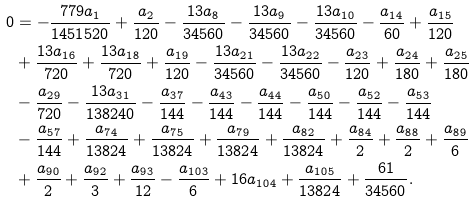<formula> <loc_0><loc_0><loc_500><loc_500>0 & = - \frac { 7 7 9 a _ { 1 } } { 1 4 5 1 5 2 0 } + \frac { a _ { 2 } } { 1 2 0 } - \frac { 1 3 a _ { 8 } } { 3 4 5 6 0 } - \frac { 1 3 a _ { 9 } } { 3 4 5 6 0 } - \frac { 1 3 a _ { 1 0 } } { 3 4 5 6 0 } - \frac { a _ { 1 4 } } { 6 0 } + \frac { a _ { 1 5 } } { 1 2 0 } \\ & + \frac { 1 3 a _ { 1 6 } } { 7 2 0 } + \frac { 1 3 a _ { 1 8 } } { 7 2 0 } + \frac { a _ { 1 9 } } { 1 2 0 } - \frac { 1 3 a _ { 2 1 } } { 3 4 5 6 0 } - \frac { 1 3 a _ { 2 2 } } { 3 4 5 6 0 } - \frac { a _ { 2 3 } } { 1 2 0 } + \frac { a _ { 2 4 } } { 1 8 0 } + \frac { a _ { 2 5 } } { 1 8 0 } \\ & - \frac { a _ { 2 9 } } { 7 2 0 } - \frac { 1 3 a _ { 3 1 } } { 1 3 8 2 4 0 } - \frac { a _ { 3 7 } } { 1 4 4 } - \frac { a _ { 4 3 } } { 1 4 4 } - \frac { a _ { 4 4 } } { 1 4 4 } - \frac { a _ { 5 0 } } { 1 4 4 } - \frac { a _ { 5 2 } } { 1 4 4 } - \frac { a _ { 5 3 } } { 1 4 4 } \\ & - \frac { a _ { 5 7 } } { 1 4 4 } + \frac { a _ { 7 4 } } { 1 3 8 2 4 } + \frac { a _ { 7 5 } } { 1 3 8 2 4 } + \frac { a _ { 7 9 } } { 1 3 8 2 4 } + \frac { a _ { 8 2 } } { 1 3 8 2 4 } + \frac { a _ { 8 4 } } { 2 } + \frac { a _ { 8 8 } } { 2 } + \frac { a _ { 8 9 } } { 6 } \\ & + \frac { a _ { 9 0 } } { 2 } + \frac { a _ { 9 2 } } { 3 } + \frac { a _ { 9 3 } } { 1 2 } - \frac { a _ { 1 0 3 } } { 6 } + 1 6 a _ { 1 0 4 } + \frac { a _ { 1 0 5 } } { 1 3 8 2 4 } + \frac { 6 1 } { 3 4 5 6 0 } .</formula> 